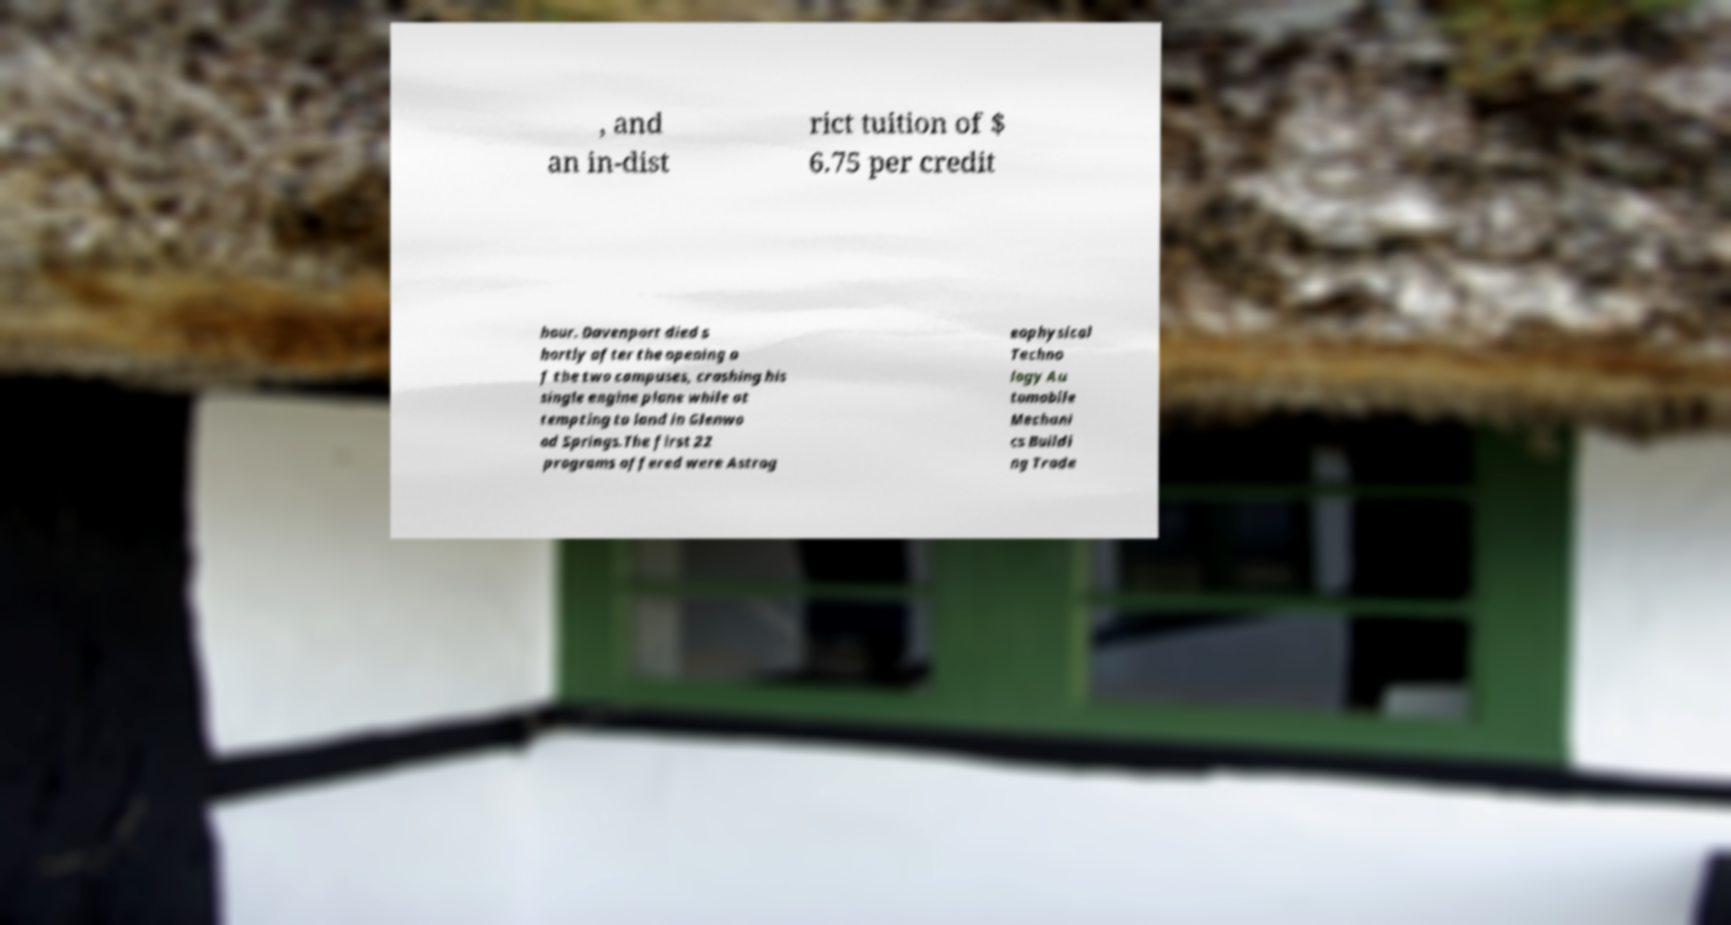Could you assist in decoding the text presented in this image and type it out clearly? , and an in-dist rict tuition of $ 6.75 per credit hour. Davenport died s hortly after the opening o f the two campuses, crashing his single engine plane while at tempting to land in Glenwo od Springs.The first 22 programs offered were Astrog eophysical Techno logy Au tomobile Mechani cs Buildi ng Trade 